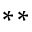<formula> <loc_0><loc_0><loc_500><loc_500>^ { * * }</formula> 